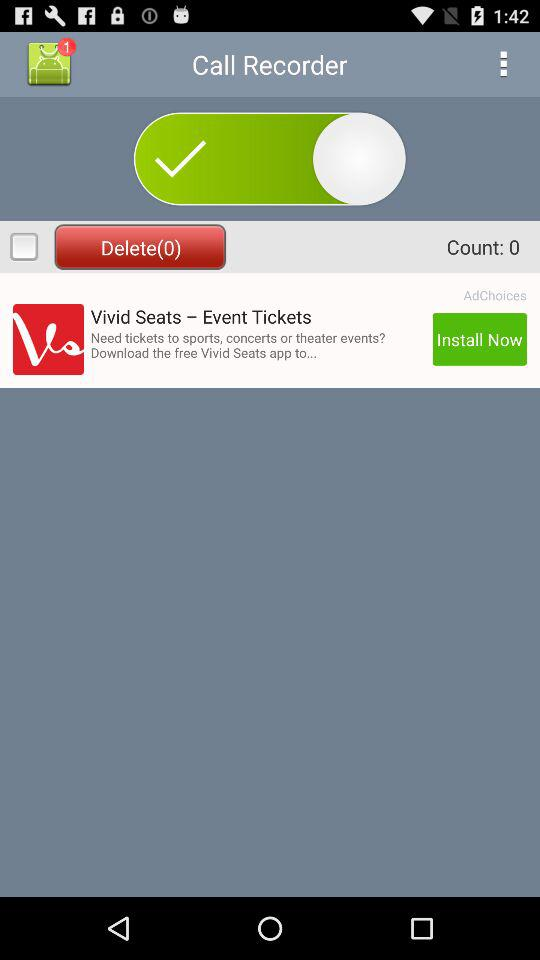What is the count? The count is 0. 